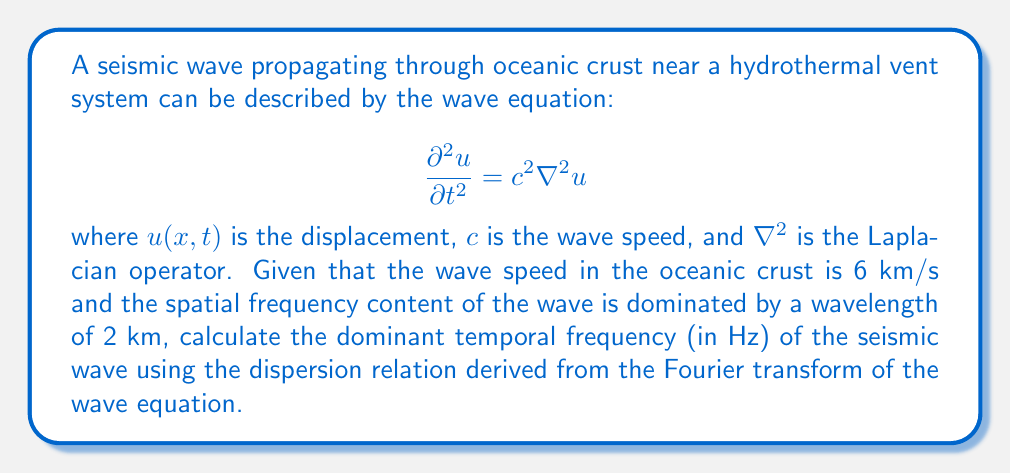Solve this math problem. To solve this problem, we'll follow these steps:

1) First, recall that the Fourier transform of the wave equation leads to the dispersion relation:

   $$\omega^2 = c^2 k^2$$

   where $\omega$ is the angular frequency and $k$ is the wavenumber.

2) We're given the wave speed $c = 6$ km/s and the dominant wavelength $\lambda = 2$ km.

3) The wavenumber $k$ is related to the wavelength $\lambda$ by:

   $$k = \frac{2\pi}{\lambda}$$

4) Substituting the given wavelength:

   $$k = \frac{2\pi}{2 \text{ km}} = \pi \text{ km}^{-1}$$

5) Now we can use the dispersion relation to find $\omega$:

   $$\omega^2 = c^2 k^2 = (6 \text{ km/s})^2 (\pi \text{ km}^{-1})^2 = 36\pi^2 \text{ s}^{-2}$$

6) Taking the square root:

   $$\omega = 6\pi \text{ s}^{-1}$$

7) To convert from angular frequency to frequency in Hz, we use:

   $$f = \frac{\omega}{2\pi}$$

8) Substituting our value for $\omega$:

   $$f = \frac{6\pi}{2\pi} = 3 \text{ Hz}$$

Therefore, the dominant temporal frequency of the seismic wave is 3 Hz.
Answer: 3 Hz 